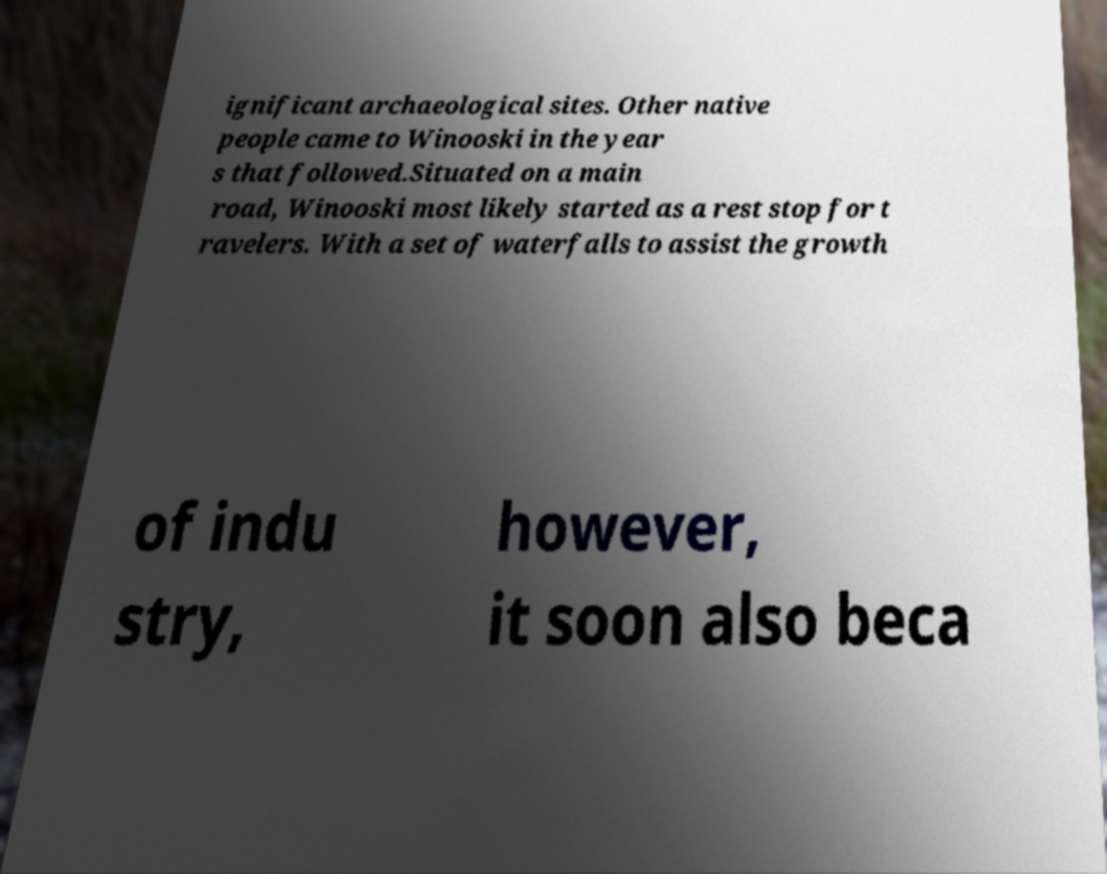For documentation purposes, I need the text within this image transcribed. Could you provide that? ignificant archaeological sites. Other native people came to Winooski in the year s that followed.Situated on a main road, Winooski most likely started as a rest stop for t ravelers. With a set of waterfalls to assist the growth of indu stry, however, it soon also beca 